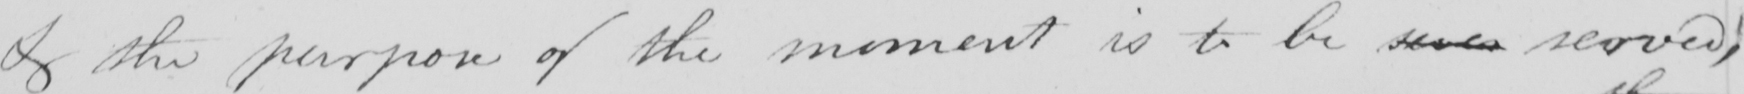Transcribe the text shown in this historical manuscript line. & the purpose of the moment is to be seve served; 